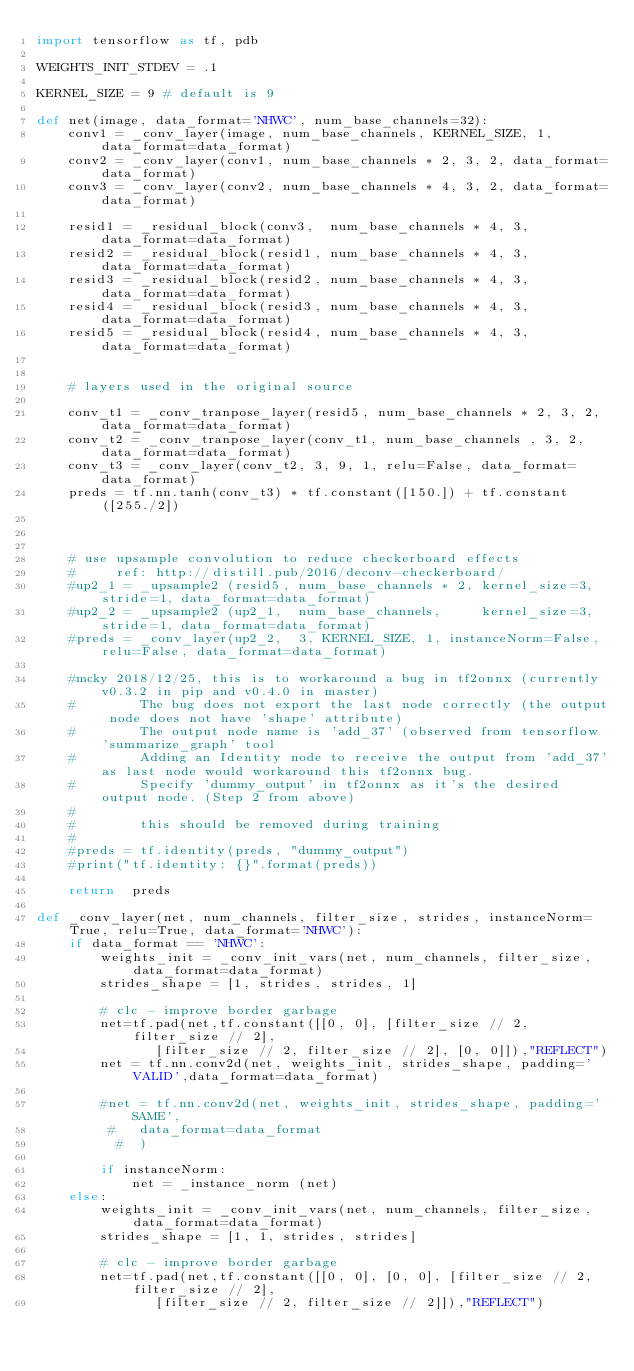<code> <loc_0><loc_0><loc_500><loc_500><_Python_>import tensorflow as tf, pdb

WEIGHTS_INIT_STDEV = .1

KERNEL_SIZE = 9 # default is 9

def net(image, data_format='NHWC', num_base_channels=32):
    conv1 = _conv_layer(image, num_base_channels, KERNEL_SIZE, 1, data_format=data_format)
    conv2 = _conv_layer(conv1, num_base_channels * 2, 3, 2, data_format=data_format)
    conv3 = _conv_layer(conv2, num_base_channels * 4, 3, 2, data_format=data_format)

    resid1 = _residual_block(conv3,  num_base_channels * 4, 3, data_format=data_format)
    resid2 = _residual_block(resid1, num_base_channels * 4, 3, data_format=data_format)
    resid3 = _residual_block(resid2, num_base_channels * 4, 3, data_format=data_format)
    resid4 = _residual_block(resid3, num_base_channels * 4, 3, data_format=data_format)
    resid5 = _residual_block(resid4, num_base_channels * 4, 3, data_format=data_format)
    
    
    # layers used in the original source

    conv_t1 = _conv_tranpose_layer(resid5, num_base_channels * 2, 3, 2, data_format=data_format)
    conv_t2 = _conv_tranpose_layer(conv_t1, num_base_channels , 3, 2, data_format=data_format)
    conv_t3 = _conv_layer(conv_t2, 3, 9, 1, relu=False, data_format=data_format)
    preds = tf.nn.tanh(conv_t3) * tf.constant([150.]) + tf.constant([255./2])

    
    
    # use upsample convolution to reduce checkerboard effects
    #     ref: http://distill.pub/2016/deconv-checkerboard/
    #up2_1 = _upsample2 (resid5, num_base_channels * 2, kernel_size=3, stride=1, data_format=data_format)
    #up2_2 = _upsample2 (up2_1,  num_base_channels,     kernel_size=3, stride=1, data_format=data_format)
    #preds = _conv_layer(up2_2,  3, KERNEL_SIZE, 1, instanceNorm=False, relu=False, data_format=data_format)

    #mcky 2018/12/25, this is to workaround a bug in tf2onnx (currently v0.3.2 in pip and v0.4.0 in master)
    #        The bug does not export the last node correctly (the output node does not have 'shape' attribute)
    #        The output node name is 'add_37' (observed from tensorflow 'summarize_graph' tool
    #        Adding an Identity node to receive the output from 'add_37'as last node would workaround this tf2onnx bug.
    #        Specify 'dummy_output' in tf2onnx as it's the desired output node. (Step 2 from above)
    #
    #        this should be removed during training
    #
    #preds = tf.identity(preds, "dummy_output")
    #print("tf.identity: {}".format(preds))
    
    return  preds

def _conv_layer(net, num_channels, filter_size, strides, instanceNorm=True, relu=True, data_format='NHWC'):
    if data_format == 'NHWC':
        weights_init = _conv_init_vars(net, num_channels, filter_size, data_format=data_format)
        strides_shape = [1, strides, strides, 1]
    
        # clc - improve border garbage
        net=tf.pad(net,tf.constant([[0, 0], [filter_size // 2, filter_size // 2],
               [filter_size // 2, filter_size // 2], [0, 0]]),"REFLECT")
        net = tf.nn.conv2d(net, weights_init, strides_shape, padding='VALID',data_format=data_format)
    
        #net = tf.nn.conv2d(net, weights_init, strides_shape, padding='SAME',
         #   data_format=data_format
          #  )

        if instanceNorm:
            net = _instance_norm (net)
    else:
        weights_init = _conv_init_vars(net, num_channels, filter_size, data_format=data_format)
        strides_shape = [1, 1, strides, strides]

        # clc - improve border garbage
        net=tf.pad(net,tf.constant([[0, 0], [0, 0], [filter_size // 2, filter_size // 2],
               [filter_size // 2, filter_size // 2]]),"REFLECT")</code> 